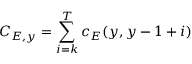Convert formula to latex. <formula><loc_0><loc_0><loc_500><loc_500>C _ { E , y } = \sum _ { i = k } ^ { T } c _ { E } ( y , y - 1 + i )</formula> 